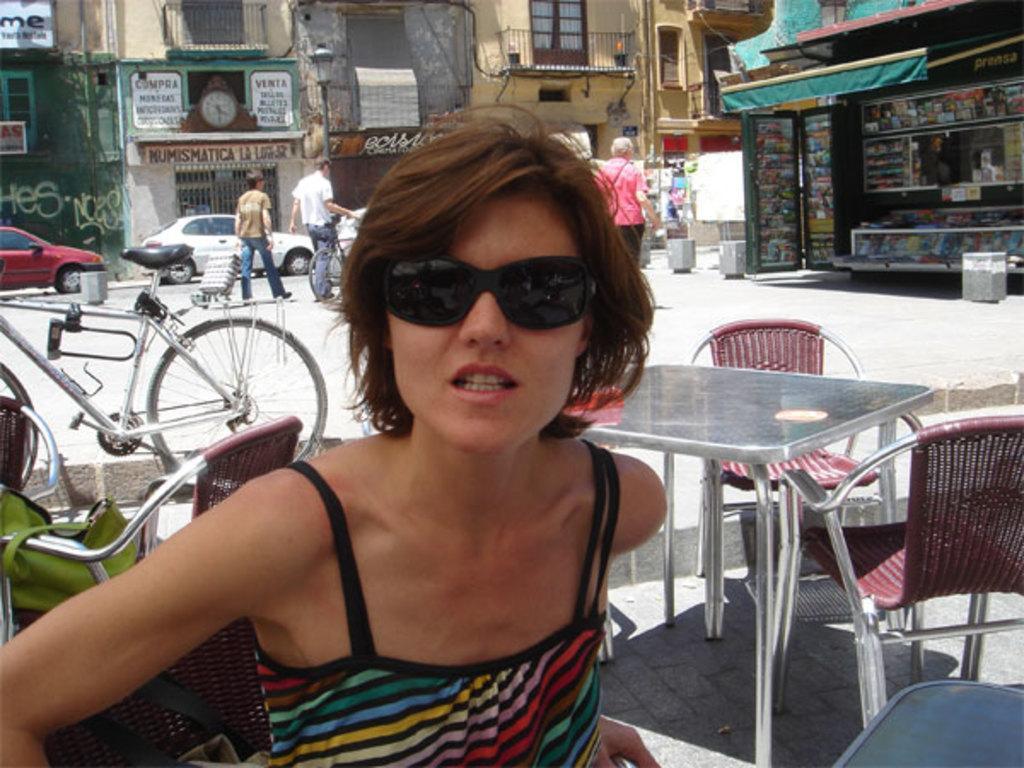Can you describe this image briefly? In this image we can see a lady wearing goggles. In the back there are chairs and table. Also there is a cycle. In the background there are vehicles and few people. Also there are buildings with windows. Also there is a clock on the wall. There are boards with text. 